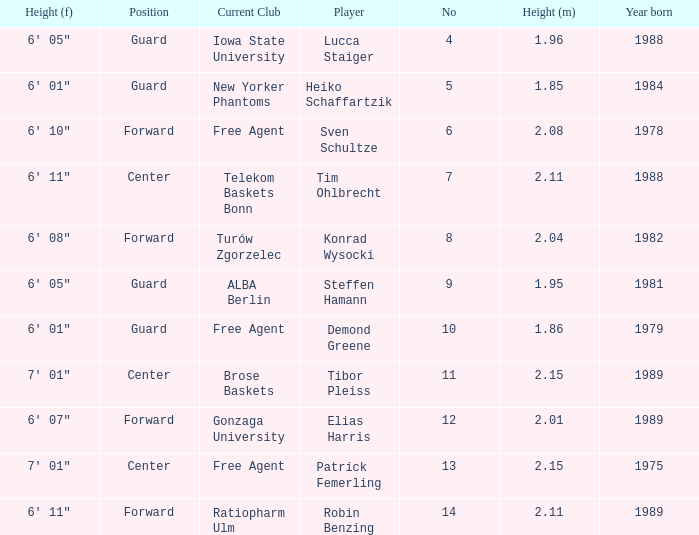Name the height for steffen hamann 6' 05". 